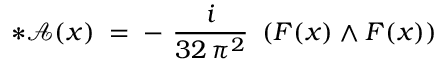<formula> <loc_0><loc_0><loc_500><loc_500>* { \mathcal { A } } ( x ) \, = \, - \frac { i } { 3 2 \, \pi ^ { 2 } } \left ( F ( x ) \wedge F ( x ) \right )</formula> 